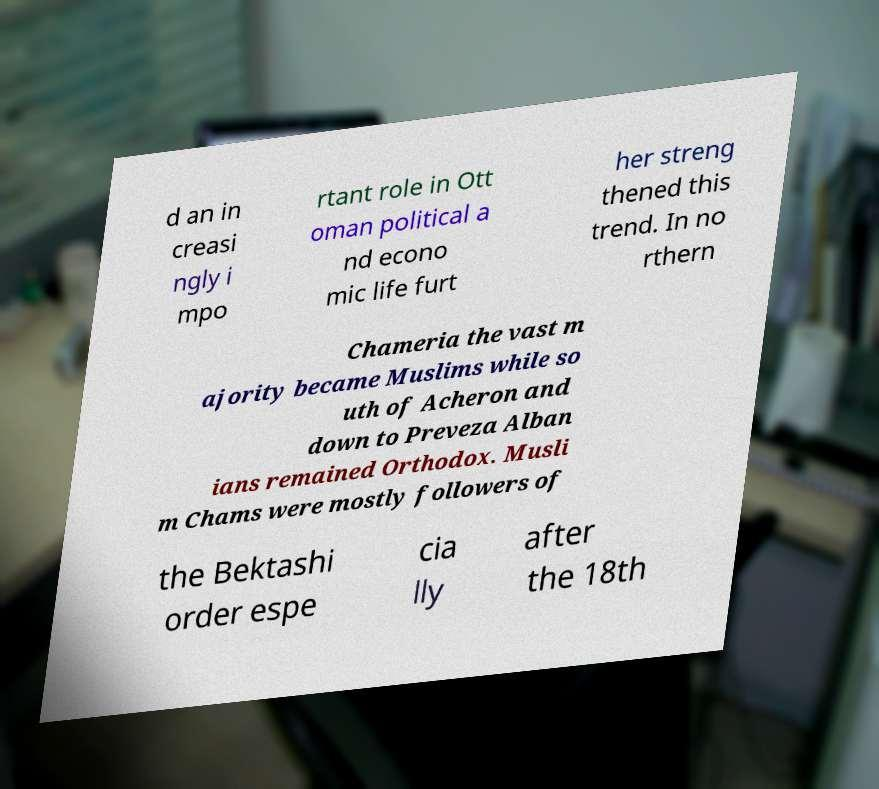Can you accurately transcribe the text from the provided image for me? d an in creasi ngly i mpo rtant role in Ott oman political a nd econo mic life furt her streng thened this trend. In no rthern Chameria the vast m ajority became Muslims while so uth of Acheron and down to Preveza Alban ians remained Orthodox. Musli m Chams were mostly followers of the Bektashi order espe cia lly after the 18th 